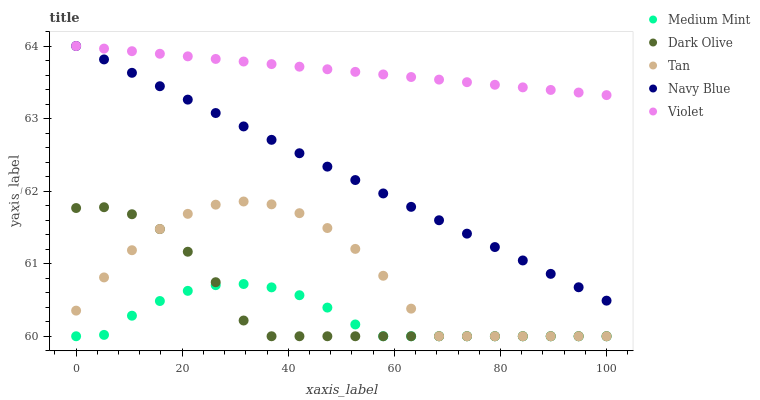Does Medium Mint have the minimum area under the curve?
Answer yes or no. Yes. Does Violet have the maximum area under the curve?
Answer yes or no. Yes. Does Navy Blue have the minimum area under the curve?
Answer yes or no. No. Does Navy Blue have the maximum area under the curve?
Answer yes or no. No. Is Violet the smoothest?
Answer yes or no. Yes. Is Tan the roughest?
Answer yes or no. Yes. Is Navy Blue the smoothest?
Answer yes or no. No. Is Navy Blue the roughest?
Answer yes or no. No. Does Medium Mint have the lowest value?
Answer yes or no. Yes. Does Navy Blue have the lowest value?
Answer yes or no. No. Does Violet have the highest value?
Answer yes or no. Yes. Does Tan have the highest value?
Answer yes or no. No. Is Dark Olive less than Violet?
Answer yes or no. Yes. Is Violet greater than Tan?
Answer yes or no. Yes. Does Violet intersect Navy Blue?
Answer yes or no. Yes. Is Violet less than Navy Blue?
Answer yes or no. No. Is Violet greater than Navy Blue?
Answer yes or no. No. Does Dark Olive intersect Violet?
Answer yes or no. No. 